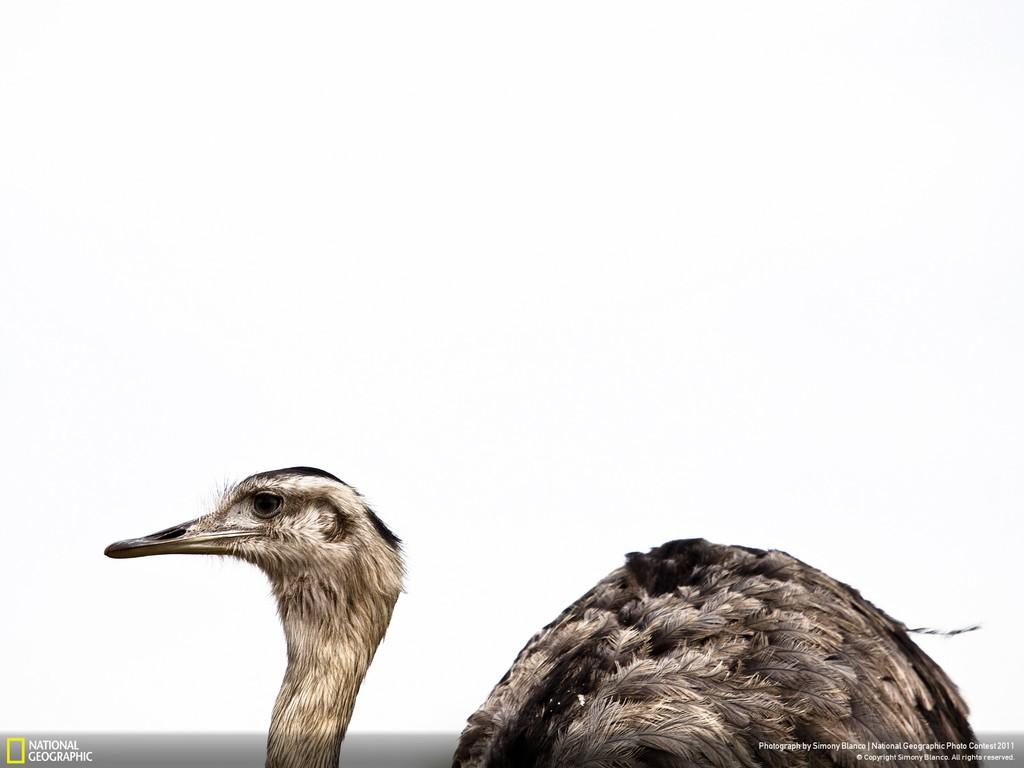What type of animal is in the image? There is a bird in the image. Where is the bird located in the image? The bird is in the center of the image. What scientific discovery is the bird making in the image? There is no indication of a scientific discovery being made in the image; it simply features a bird in the center. 